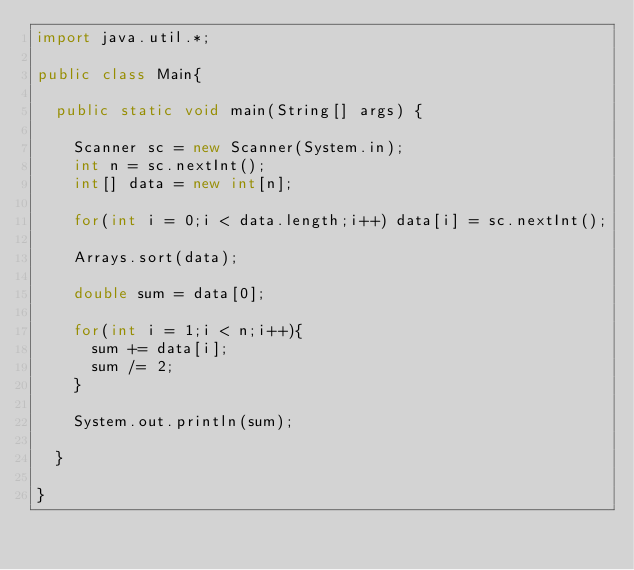Convert code to text. <code><loc_0><loc_0><loc_500><loc_500><_Java_>import java.util.*;

public class Main{

  public static void main(String[] args) {

    Scanner sc = new Scanner(System.in);
    int n = sc.nextInt();
    int[] data = new int[n];

    for(int i = 0;i < data.length;i++) data[i] = sc.nextInt();

    Arrays.sort(data);

    double sum = data[0];

    for(int i = 1;i < n;i++){
      sum += data[i];
      sum /= 2;
    }

    System.out.println(sum);

  }

}
</code> 